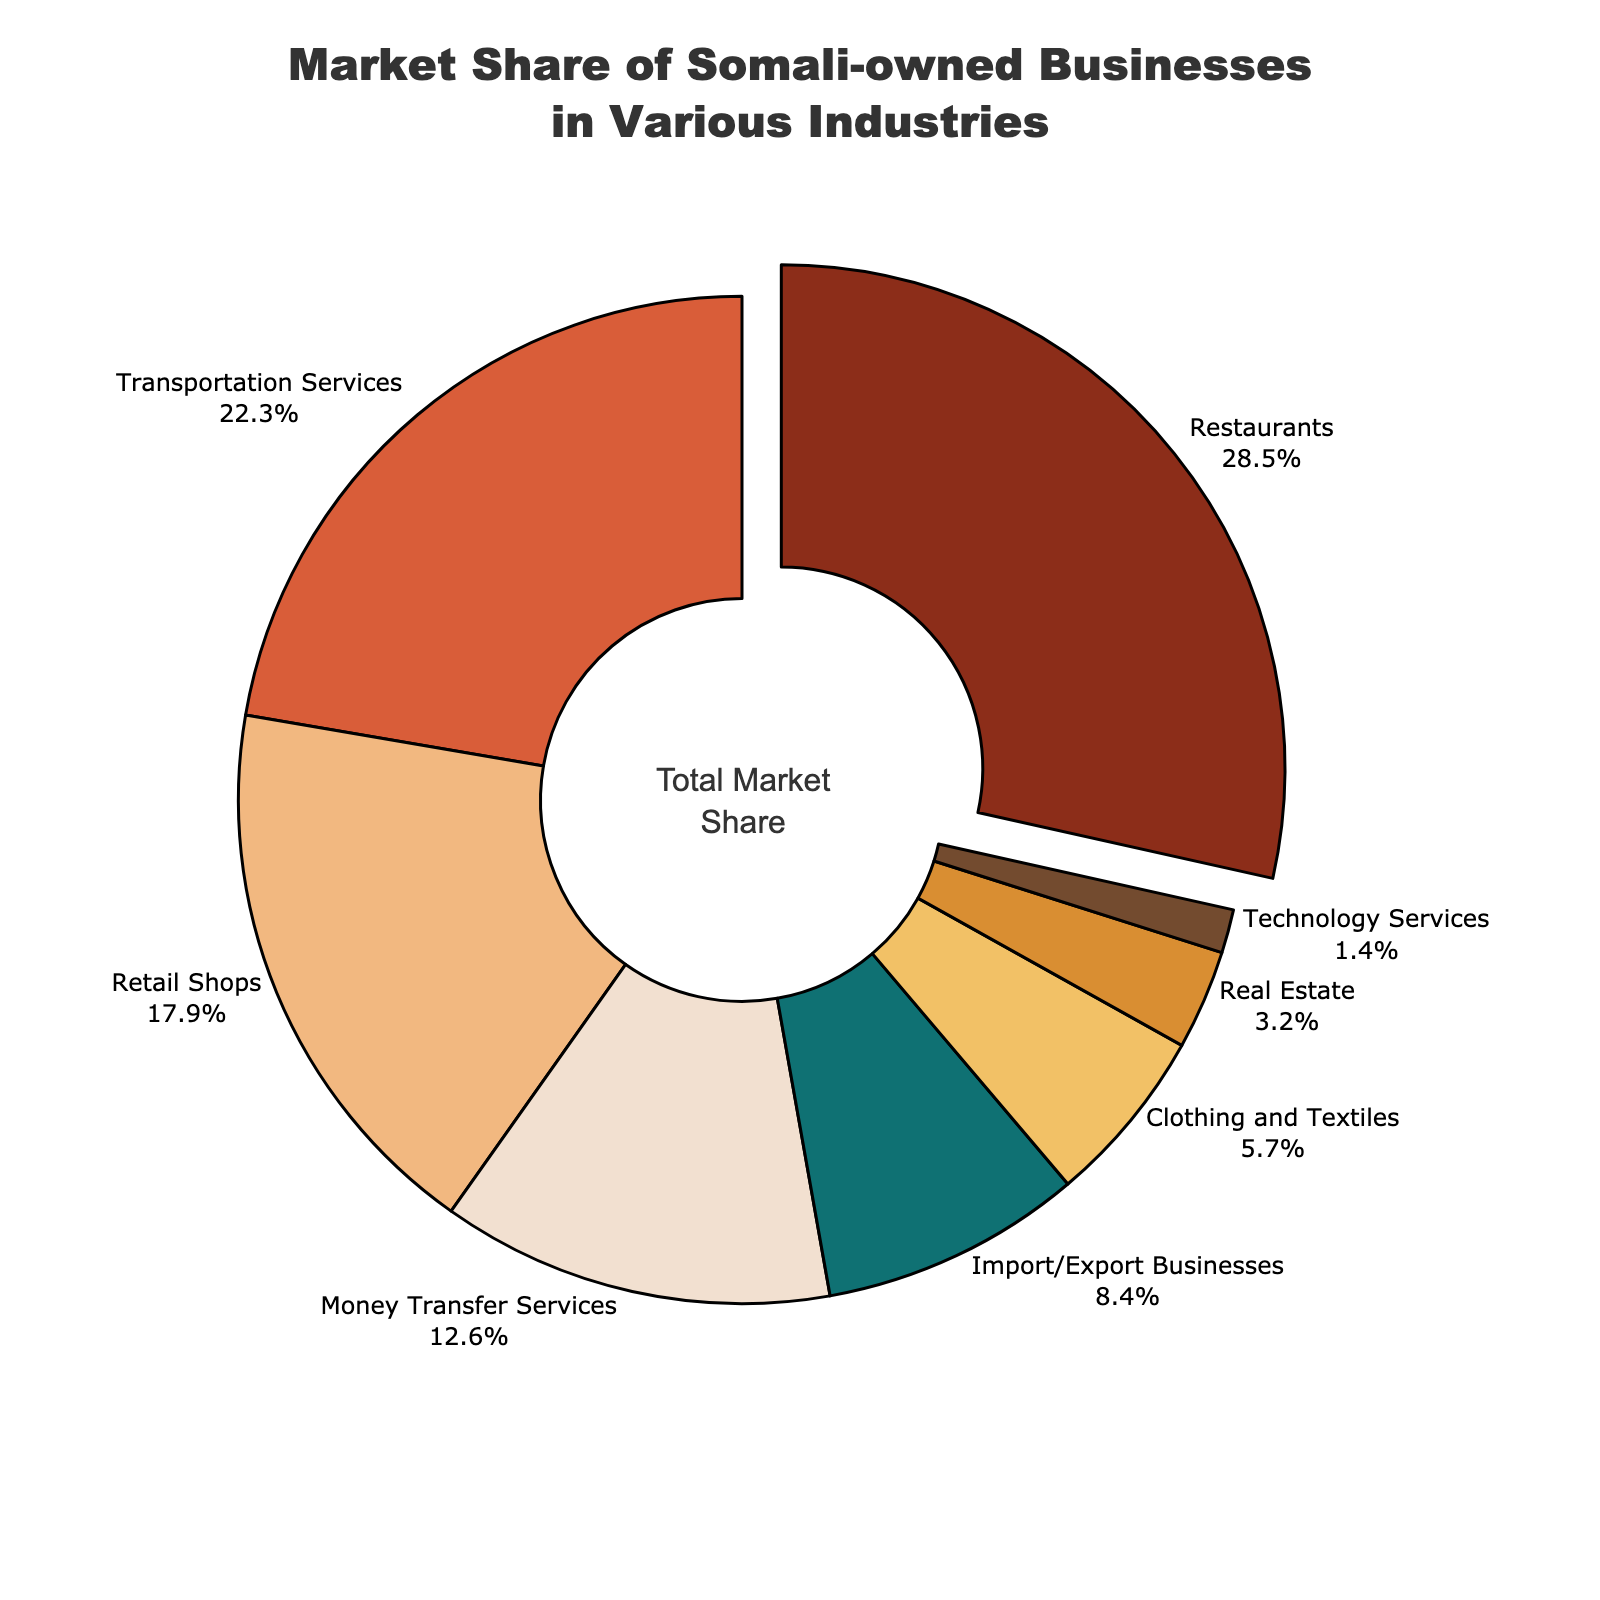Which industry has the highest market share among Somali-owned businesses? The largest slice in the pie chart, distinguished by being slightly pulled out, represents Restaurants, indicating it has the highest market share.
Answer: Restaurants What's the total market share of Retail Shops and Clothing and Textiles combined? The market share for Retail Shops is 17.9% and for Clothing and Textiles is 5.7%. Adding these together, 17.9% + 5.7% = 23.6%.
Answer: 23.6% How much larger is the market share of Restaurants compared to Technology Services? The market share for Restaurants is 28.5%, and for Technology Services, it is 1.4%. The difference is 28.5% - 1.4% = 27.1%.
Answer: 27.1% Which industry has a larger market share: Money Transfer Services or Import/Export Businesses? Comparing the slices, Money Transfer Services has a market share of 12.6%, whereas Import/Export Businesses have 8.4%. Therefore, Money Transfer Services have a larger share.
Answer: Money Transfer Services What is the combined market share of the three smallest industries? The three smallest industries are Technology Services (1.4%), Real Estate (3.2%), and Clothing and Textiles (5.7%). Adding these, 1.4% + 3.2% + 5.7% = 10.3%.
Answer: 10.3% How does the market share of Transportation Services compare to Import/Export Businesses? Transportation Services has a market share of 22.3%, while Import/Export Businesses have 8.4%. Thus, Transportation Services have a larger market share.
Answer: Transportation Services What portion of the chart is represented by the three largest industries? The three largest industries are Restaurants (28.5%), Transportation Services (22.3%), and Retail Shops (17.9%). Summing these, 28.5% + 22.3% + 17.9% = 68.7%.
Answer: 68.7% Which industry is represented by the red color? By looking at the visual representation in the chart, the industry marked in red typically is labeled, which corresponds to Real Estate.
Answer: Real Estate 